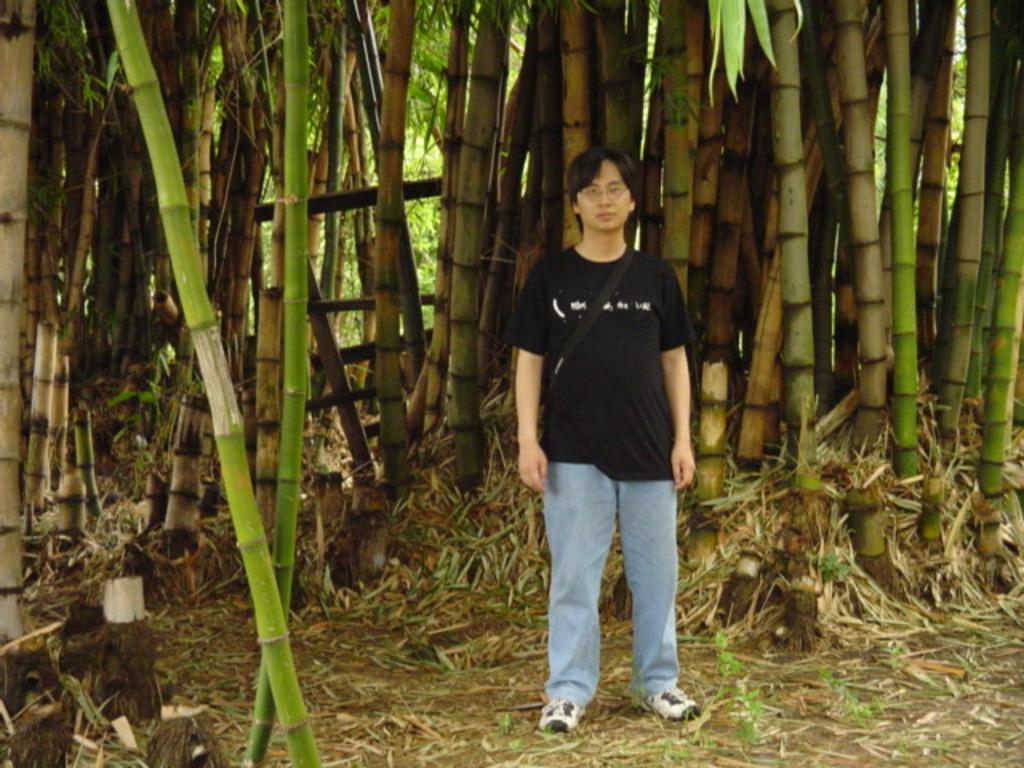What is the main subject in the center of the image? There is a man in the center of the image. What can be seen in the background of the image? There are trees in the background of the image. What type of eggnog is being served in the image? There is no eggnog present in the image; it only features a man and trees in the background. 